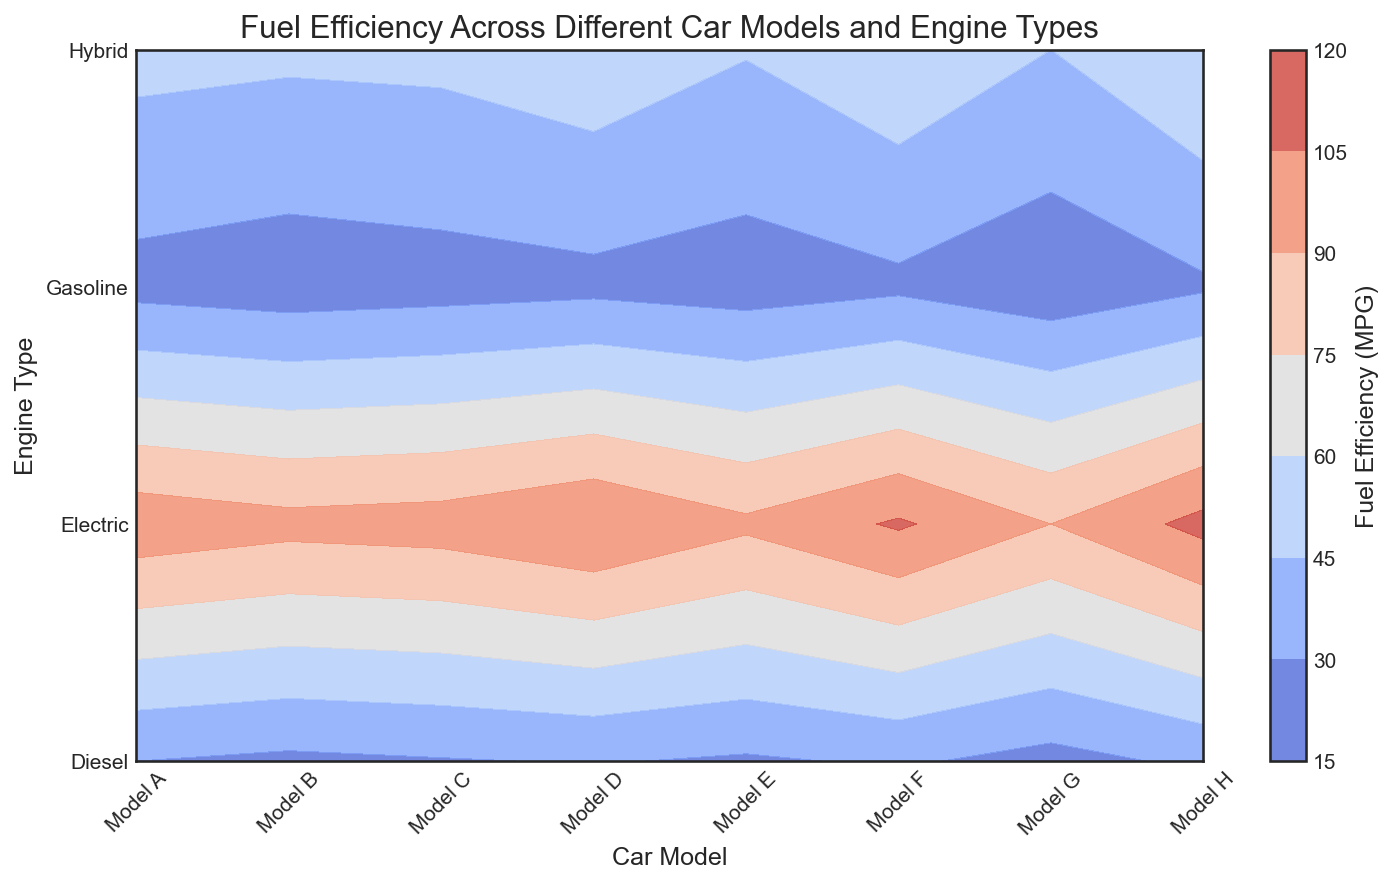What car model and engine type has the highest fuel efficiency? Observe the color gradient on the contour plot. The brightest or deepest color indicates the highest value. Identify the corresponding car model and engine type from the axes.
Answer: Model H, Electric Which car model has the least fuel-efficient gasoline engine? Find the section of the plot that corresponds to gasoline engines by checking the y-axis labels. Then look for the car model with the darkest or least visually intense color in that section.
Answer: Model G Compare the fuel efficiency of electric engines in Model A and Model H. Which is higher? Locate Model A and Model H along the x-axis, then find the sections that correspond to electric engines. Compare the colors or values.
Answer: Model H Is the average fuel efficiency higher for diesel engines or hybrid engines? Calculate the average value for each engine type by visually estimating or noting the colors' intensity for all models in each engine type category and averaging the values.
Answer: Hybrid engines Which car model shows the most significant variation in fuel efficiency across different engine types? Compare the contour regions for each car model and look for the largest range in color intensity or value across different engine types.
Answer: Model H What is the difference in fuel efficiency between the most efficient gasoline engine and the most efficient diesel engine? Identify the sections for gasoline and diesel engines, find the highest values in each, and calculate the difference.
Answer: 33 - 28 = 5 MPG Which engine type generally shows the highest fuel efficiency across all car models? Look for the generally brightest color band across all car models on the y-axis and identify the corresponding engine type.
Answer: Electric How does the fuel efficiency of Model D's hybrid engine compare to Model F's hybrid engine? Locate Model D and Model F on the x-axis, then move to the sections for hybrid engines, and compare the values or color intensity.
Answer: Model F’s hybrid engine is more efficient What is the average fuel efficiency of gasoline engines across all car models? Sum the fuel efficiency values for gasoline engines across all car models and divide by the number of car models (8).
Answer: (25 + 22 + 24 + 26 + 23 + 27 + 20 + 28) / 8 = 24.38 MPG 